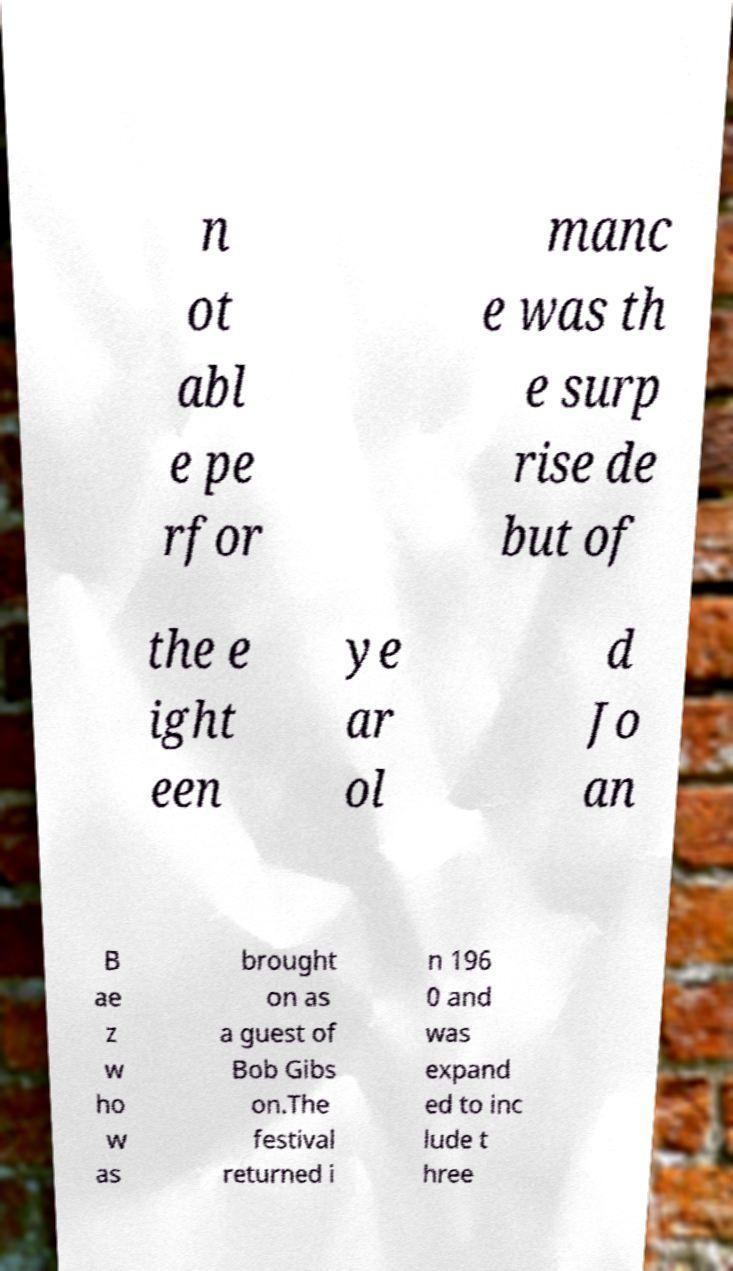Can you read and provide the text displayed in the image?This photo seems to have some interesting text. Can you extract and type it out for me? n ot abl e pe rfor manc e was th e surp rise de but of the e ight een ye ar ol d Jo an B ae z w ho w as brought on as a guest of Bob Gibs on.The festival returned i n 196 0 and was expand ed to inc lude t hree 